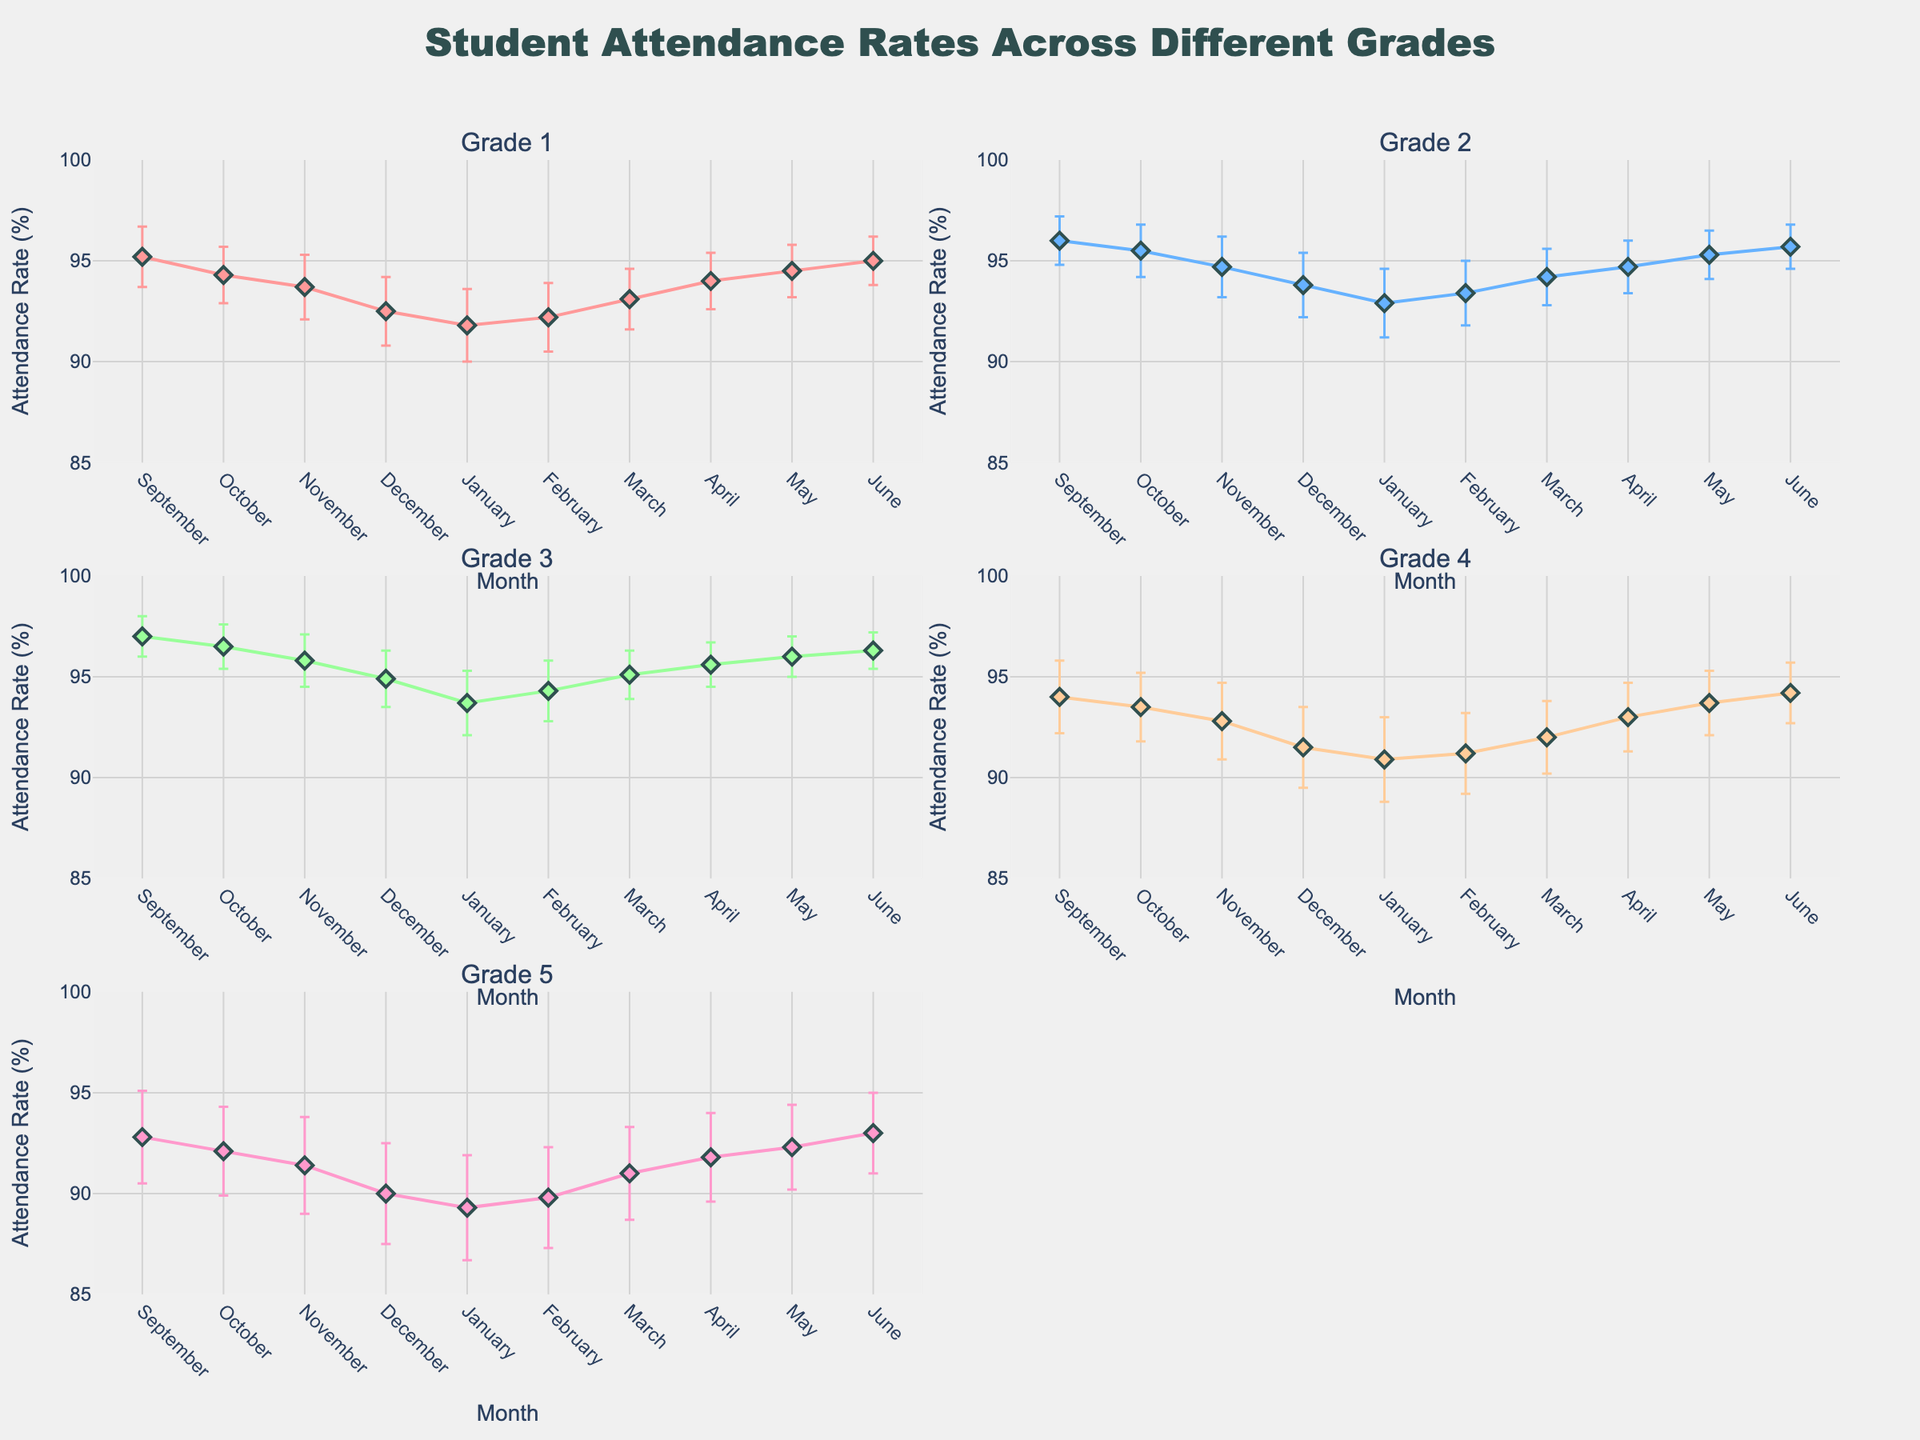What is the title of the figure? The title is located at the top center of the figure and reads: "Student Attendance Rates Across Different Grades".
Answer: Student Attendance Rates Across Different Grades What grade has the highest attendance rate in March? Locate the subplot corresponding to March and identify the highest attendance rate among all grades. Grade 3 has an attendance rate of 95.1% in March, which is the highest among all grades.
Answer: Grade 3 Which month shows the lowest attendance rate for Grade 5? Looking at the subplot for Grade 5, identify the lowest attendance rate among all months. December has the lowest attendance rate for Grade 5 at 90.0%.
Answer: December How does the attendance rate in January compare between Grade 1 and Grade 3? Find the January points for both Grade 1 and Grade 3 in their respective subplots, then compare the values. Grade 1 has an attendance rate of 91.8%, while Grade 3 has a rate of 93.7% in January.
Answer: Grade 3 is higher What is the average attendance rate of Grade 4 from September to December? Sum the attendance rates from September to December for Grade 4 and divide by the number of months. (94.0 + 93.5 + 92.8 + 91.5) / 4 = 92.95%
Answer: 92.95% Which grade shows the least variation in attendance rates throughout the year? To determine the variation, compare the difference between the highest and lowest attendance rates in each subplot. Grade 3 has the smallest range (97.0% - 93.7% = 3.3%).
Answer: Grade 3 What is the general trend in attendance rates for Grade 4 over the school year? Observe the line in the Grade 4 subplot from September to June. The attendance rates generally start high, dip in December and January, and then gradually increase towards the end of the school year.
Answer: Starts high, dips, then increases How does the attendance rate in April for Grade 1 compare to the attendance rate in April for Grade 2? Find the attendance rates in April for both Grade 1 and Grade 2 in their respective subplots, then compare them. Grade 1 has an attendance rate of 94%, while Grade 2 has a rate of 94.7%.
Answer: Grade 2 is higher Which grade has the highest standard error in February? Locate the February points in each grade's subplot and identify the largest standard error bar. Grade 5 has the highest standard error in February at 2.5.
Answer: Grade 5 What is the difference in attendance rates between the highest and lowest months for Grade 2? Identify the highest and lowest attendance rates in the Grade 2 subplot and calculate their difference. The highest is 96.0% in September and the lowest is 92.9% in January. 96.0% - 92.9% = 3.1%.
Answer: 3.1% 